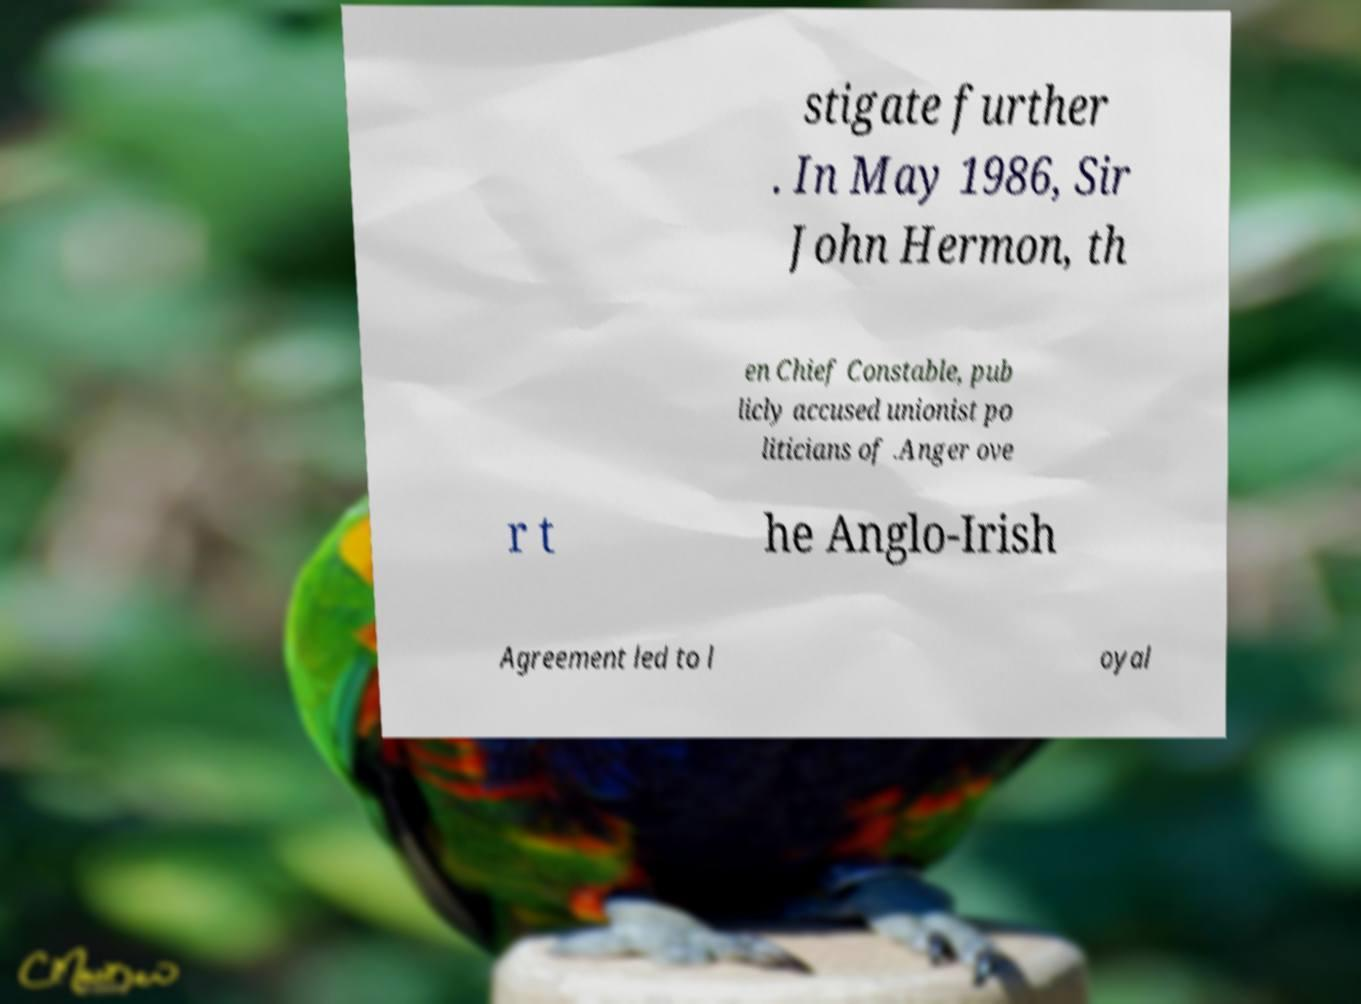Can you read and provide the text displayed in the image?This photo seems to have some interesting text. Can you extract and type it out for me? stigate further . In May 1986, Sir John Hermon, th en Chief Constable, pub licly accused unionist po liticians of .Anger ove r t he Anglo-Irish Agreement led to l oyal 